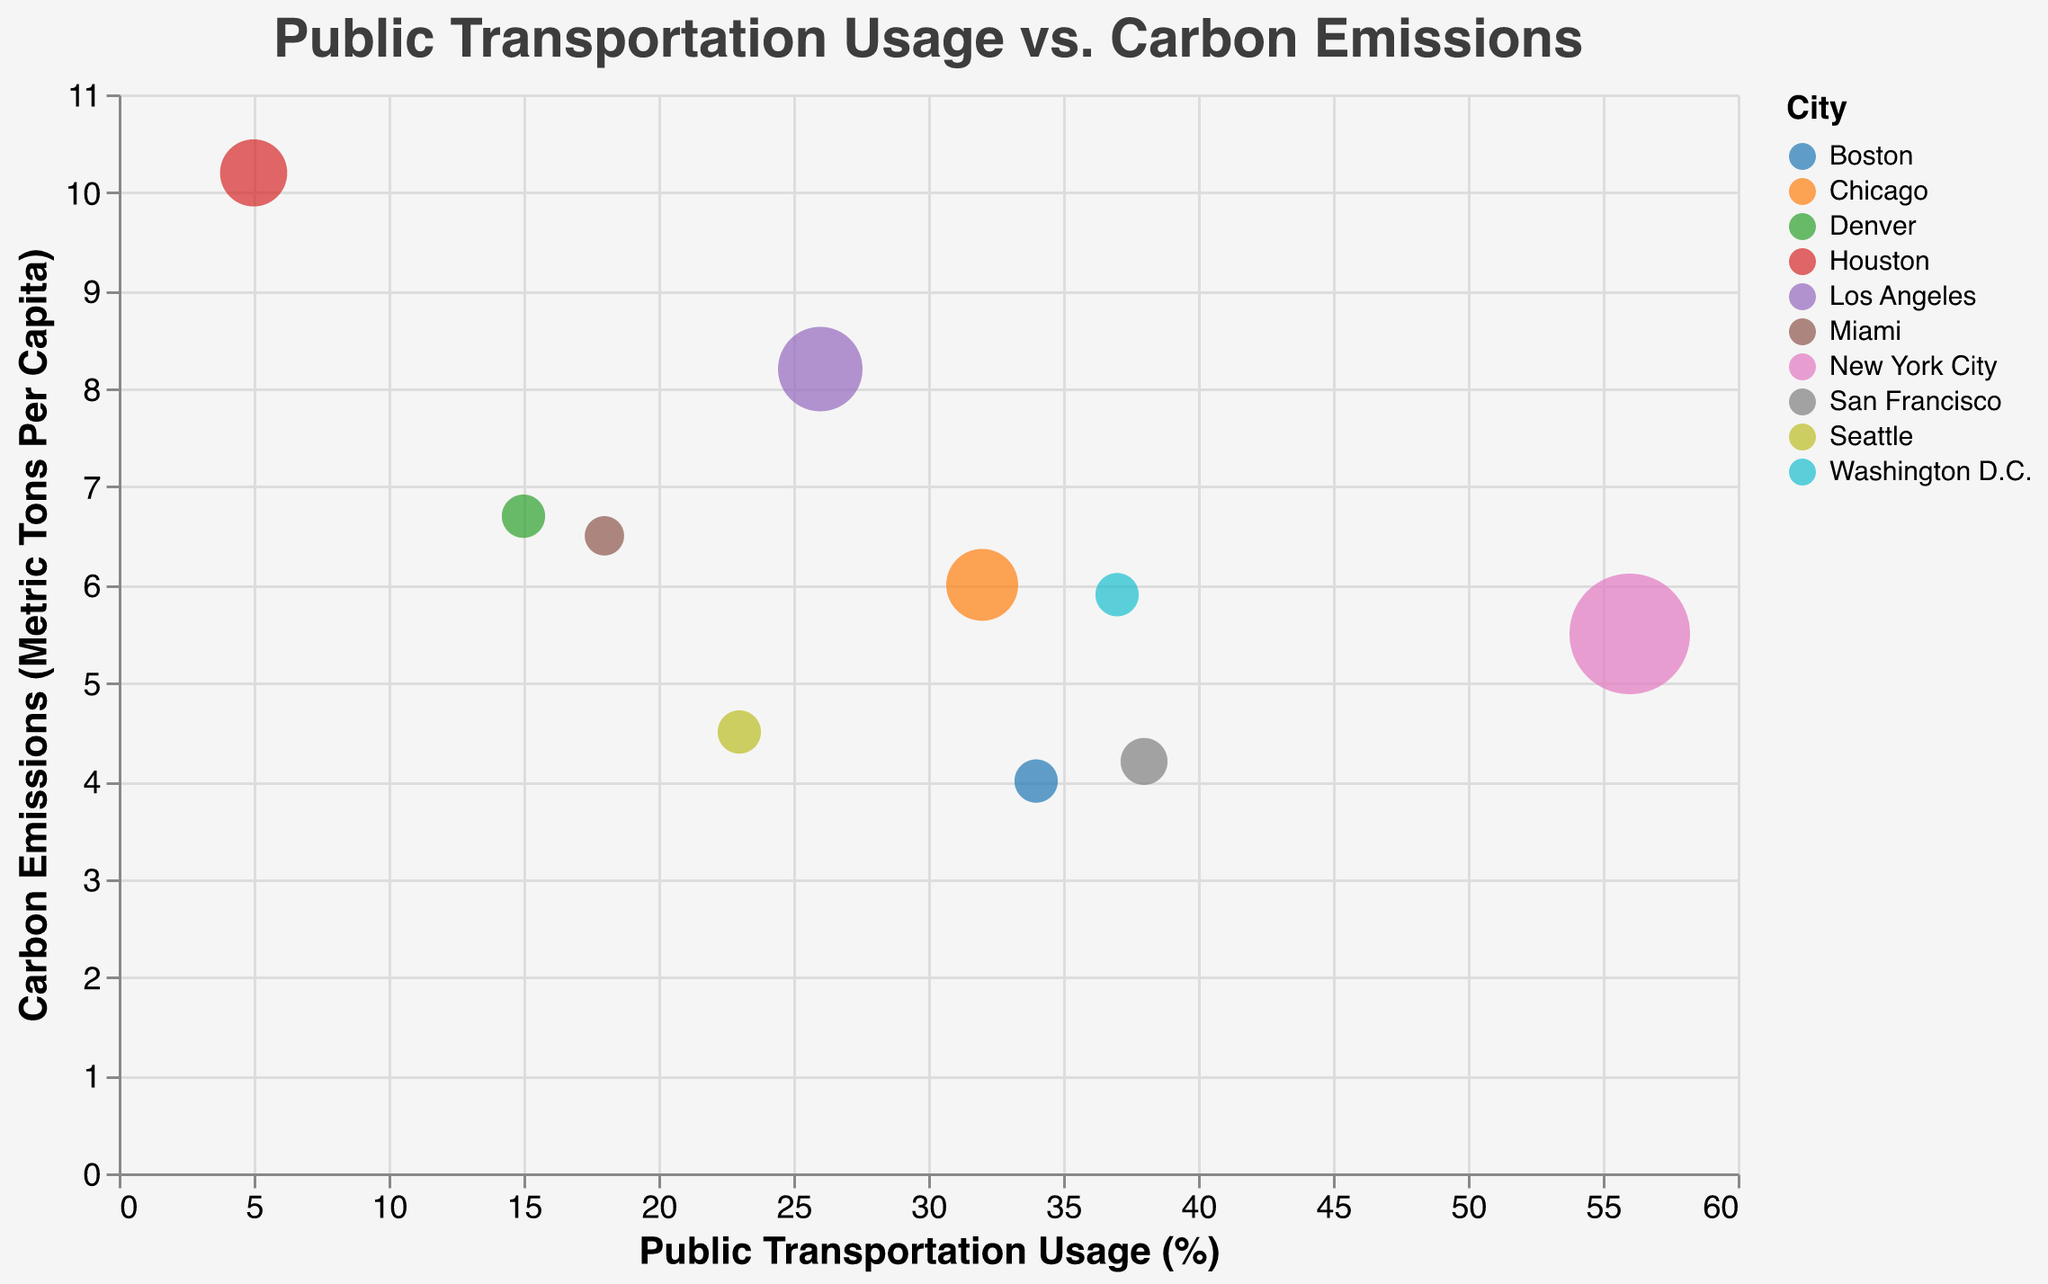What is the title of the chart? The title of the chart is displayed at the top and describes the chart's content.
Answer: Public Transportation Usage vs. Carbon Emissions Which city has the highest percentage of public transportation usage? By looking at the x-axis, we find the bubble that is furthest to the right. This bubble corresponds to New York City.
Answer: New York City What is the carbon emissions metric tons per capita for Los Angeles? Identify the bubble for Los Angeles by its color and tooltip, then read its position on the y-axis.
Answer: 8.2 Which city has the lowest carbon emissions per capita? By locating the bubble closest to the bottom of the y-axis and checking the tooltip or color, we find it corresponds to Boston.
Answer: Boston What is the relationship between public transportation usage and carbon emissions for the cities shown? The chart generally shows that higher public transportation usage tends to relate to lower carbon emissions, as seen in cities like New York City and San Francisco, whereas cities like Houston, with low public transportation usage, have higher emissions.
Answer: Inverse relationship Which city has the largest bubble size, and what does it represent? The largest bubble is identified by comparing bubble sizes. New York City has the largest bubble size, which represents an additional dimension of interest, such as population or another relevant metric.
Answer: New York City Compare the public transportation usage between San Francisco and Miami. Locate the bubbles for San Francisco and Miami, then compare their positions on the x-axis to determine their public transportation usage percentages.
Answer: San Francisco has 38%, and Miami has 18% Which city has higher carbon emissions per capita, Seattle or Denver? By comparing the y-axis positions of Seattle and Denver's bubbles, we determine which one is higher.
Answer: Denver What is the average carbon emissions per capita for New York City and San Francisco combined? Sum the emissions for both cities (5.5 + 4.2) and divide by 2 to get the average.
Answer: 4.85 How does Boston's public transportation usage compare to Chicago's? Locate the bubbles for Boston and Chicago, then compare their positions on the x-axis to determine their public transportation usage percentages.
Answer: Boston has 34% and Chicago has 32% 